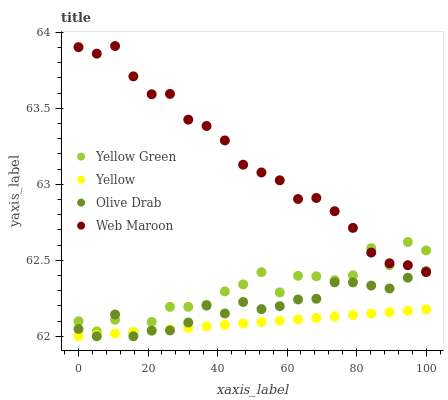Does Yellow have the minimum area under the curve?
Answer yes or no. Yes. Does Web Maroon have the maximum area under the curve?
Answer yes or no. Yes. Does Yellow Green have the minimum area under the curve?
Answer yes or no. No. Does Yellow Green have the maximum area under the curve?
Answer yes or no. No. Is Yellow the smoothest?
Answer yes or no. Yes. Is Yellow Green the roughest?
Answer yes or no. Yes. Is Web Maroon the smoothest?
Answer yes or no. No. Is Web Maroon the roughest?
Answer yes or no. No. Does Olive Drab have the lowest value?
Answer yes or no. Yes. Does Yellow Green have the lowest value?
Answer yes or no. No. Does Web Maroon have the highest value?
Answer yes or no. Yes. Does Yellow Green have the highest value?
Answer yes or no. No. Is Yellow less than Web Maroon?
Answer yes or no. Yes. Is Web Maroon greater than Yellow?
Answer yes or no. Yes. Does Yellow intersect Yellow Green?
Answer yes or no. Yes. Is Yellow less than Yellow Green?
Answer yes or no. No. Is Yellow greater than Yellow Green?
Answer yes or no. No. Does Yellow intersect Web Maroon?
Answer yes or no. No. 